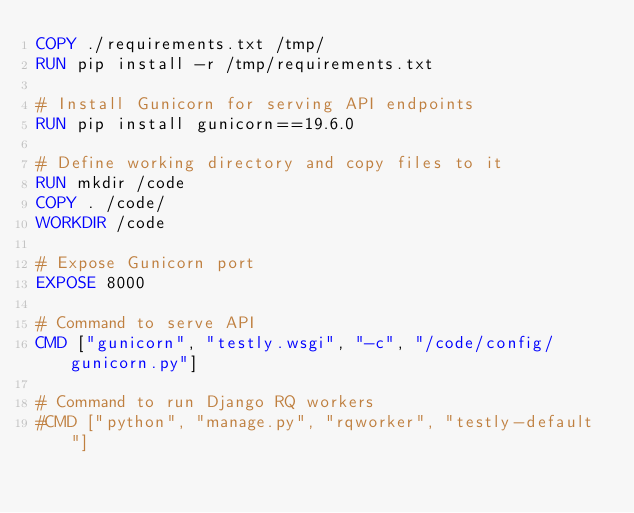<code> <loc_0><loc_0><loc_500><loc_500><_Dockerfile_>COPY ./requirements.txt /tmp/
RUN pip install -r /tmp/requirements.txt

# Install Gunicorn for serving API endpoints
RUN pip install gunicorn==19.6.0

# Define working directory and copy files to it
RUN mkdir /code
COPY . /code/
WORKDIR /code

# Expose Gunicorn port
EXPOSE 8000

# Command to serve API
CMD ["gunicorn", "testly.wsgi", "-c", "/code/config/gunicorn.py"]

# Command to run Django RQ workers
#CMD ["python", "manage.py", "rqworker", "testly-default"]
</code> 